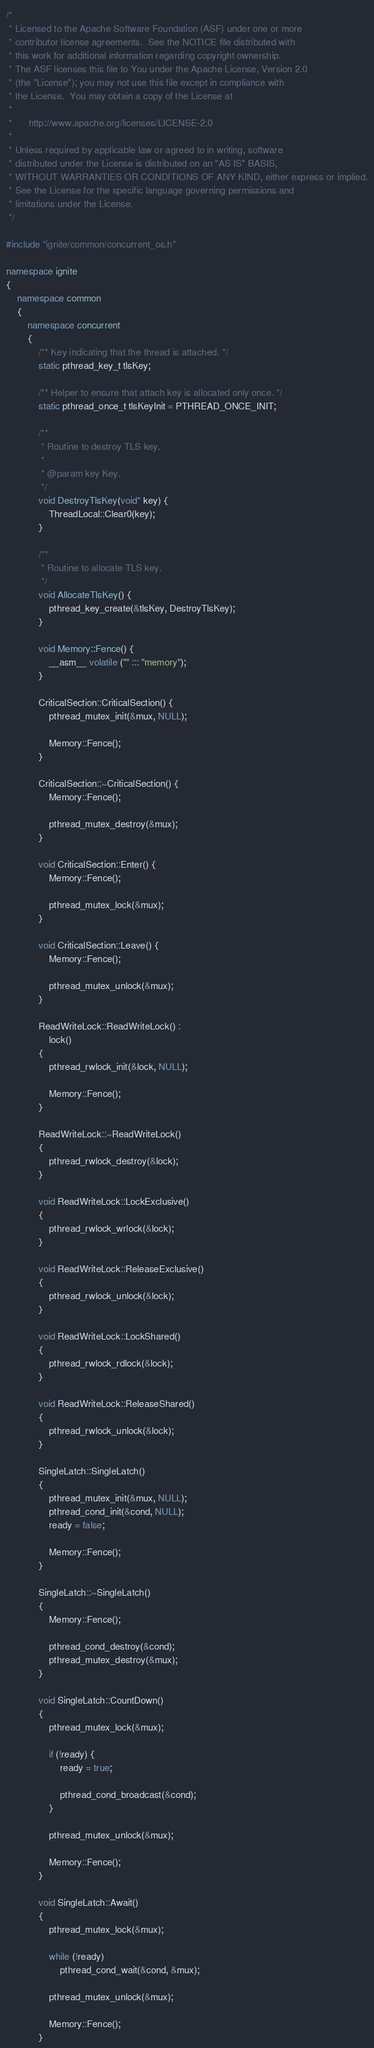<code> <loc_0><loc_0><loc_500><loc_500><_C++_>/*
 * Licensed to the Apache Software Foundation (ASF) under one or more
 * contributor license agreements.  See the NOTICE file distributed with
 * this work for additional information regarding copyright ownership.
 * The ASF licenses this file to You under the Apache License, Version 2.0
 * (the "License"); you may not use this file except in compliance with
 * the License.  You may obtain a copy of the License at
 *
 *      http://www.apache.org/licenses/LICENSE-2.0
 *
 * Unless required by applicable law or agreed to in writing, software
 * distributed under the License is distributed on an "AS IS" BASIS,
 * WITHOUT WARRANTIES OR CONDITIONS OF ANY KIND, either express or implied.
 * See the License for the specific language governing permissions and
 * limitations under the License.
 */

#include "ignite/common/concurrent_os.h"

namespace ignite
{
    namespace common
    {
        namespace concurrent
        {
            /** Key indicating that the thread is attached. */
            static pthread_key_t tlsKey;

            /** Helper to ensure that attach key is allocated only once. */
            static pthread_once_t tlsKeyInit = PTHREAD_ONCE_INIT;

            /**
             * Routine to destroy TLS key.
             *
             * @param key Key.
             */
            void DestroyTlsKey(void* key) {
                ThreadLocal::Clear0(key);
            }

            /**
             * Routine to allocate TLS key.
             */
            void AllocateTlsKey() {
                pthread_key_create(&tlsKey, DestroyTlsKey);
            }

            void Memory::Fence() {
                __asm__ volatile ("" ::: "memory");
            }

            CriticalSection::CriticalSection() {
                pthread_mutex_init(&mux, NULL);

                Memory::Fence();
            }

            CriticalSection::~CriticalSection() {
                Memory::Fence();

                pthread_mutex_destroy(&mux);
            }

            void CriticalSection::Enter() {
                Memory::Fence();

                pthread_mutex_lock(&mux);
            }

            void CriticalSection::Leave() {
                Memory::Fence();

                pthread_mutex_unlock(&mux);
            }

            ReadWriteLock::ReadWriteLock() :
                lock()
            {
                pthread_rwlock_init(&lock, NULL);

                Memory::Fence();
            }

            ReadWriteLock::~ReadWriteLock()
            {
                pthread_rwlock_destroy(&lock);
            }

            void ReadWriteLock::LockExclusive()
            {
                pthread_rwlock_wrlock(&lock);
            }

            void ReadWriteLock::ReleaseExclusive()
            {
                pthread_rwlock_unlock(&lock);
            }

            void ReadWriteLock::LockShared()
            {
                pthread_rwlock_rdlock(&lock);
            }

            void ReadWriteLock::ReleaseShared()
            {
                pthread_rwlock_unlock(&lock);
            }

            SingleLatch::SingleLatch()
            {
                pthread_mutex_init(&mux, NULL);
                pthread_cond_init(&cond, NULL);
                ready = false;

                Memory::Fence();
            }

            SingleLatch::~SingleLatch()
            {
                Memory::Fence();

                pthread_cond_destroy(&cond);
                pthread_mutex_destroy(&mux);
            }

            void SingleLatch::CountDown()
            {
                pthread_mutex_lock(&mux);

                if (!ready) {
                    ready = true;

                    pthread_cond_broadcast(&cond);
                }

                pthread_mutex_unlock(&mux);

                Memory::Fence();
            }

            void SingleLatch::Await()
            {
                pthread_mutex_lock(&mux);

                while (!ready)
                    pthread_cond_wait(&cond, &mux);

                pthread_mutex_unlock(&mux);

                Memory::Fence();
            }
</code> 